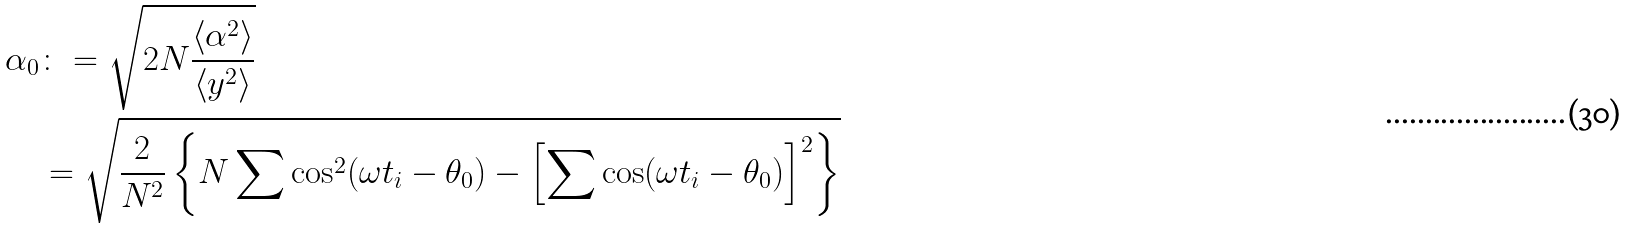<formula> <loc_0><loc_0><loc_500><loc_500>\alpha _ { 0 } & \colon = \sqrt { 2 N \frac { \left \langle \alpha ^ { 2 } \right \rangle } { \left \langle y ^ { 2 } \right \rangle } } \\ & = \sqrt { \frac { 2 } { N ^ { 2 } } \left \{ N \sum \cos ^ { 2 } ( \omega t _ { i } - \theta _ { 0 } ) - \left [ \sum \cos ( \omega t _ { i } - \theta _ { 0 } ) \right ] ^ { 2 } \right \} }</formula> 